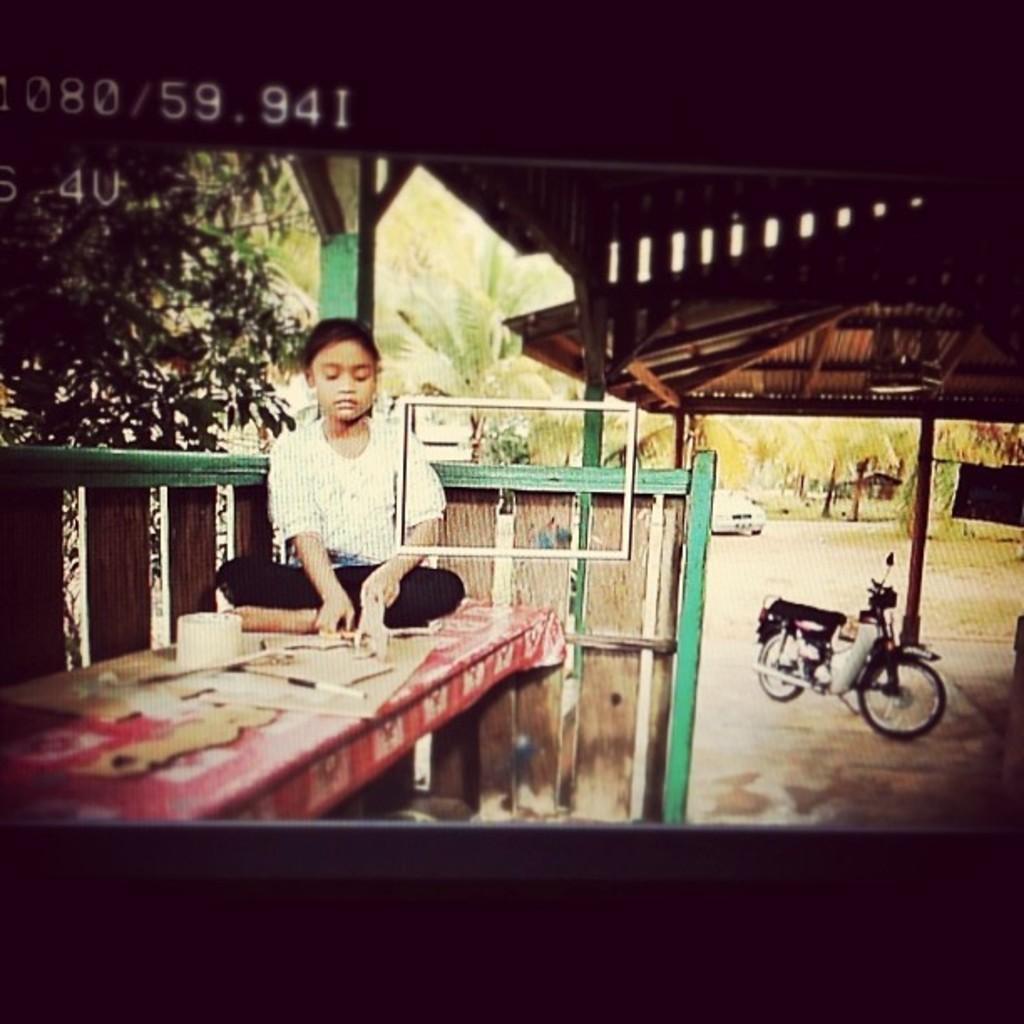Could you give a brief overview of what you see in this image? In this image I can see the person sitting on the table. On the table I can see cardboard pieces, tissue role and the red sheet. There is a bike to the side. To the left I can see the tree. There are under the house. In the back I can see many trees and the white color vehicle. 